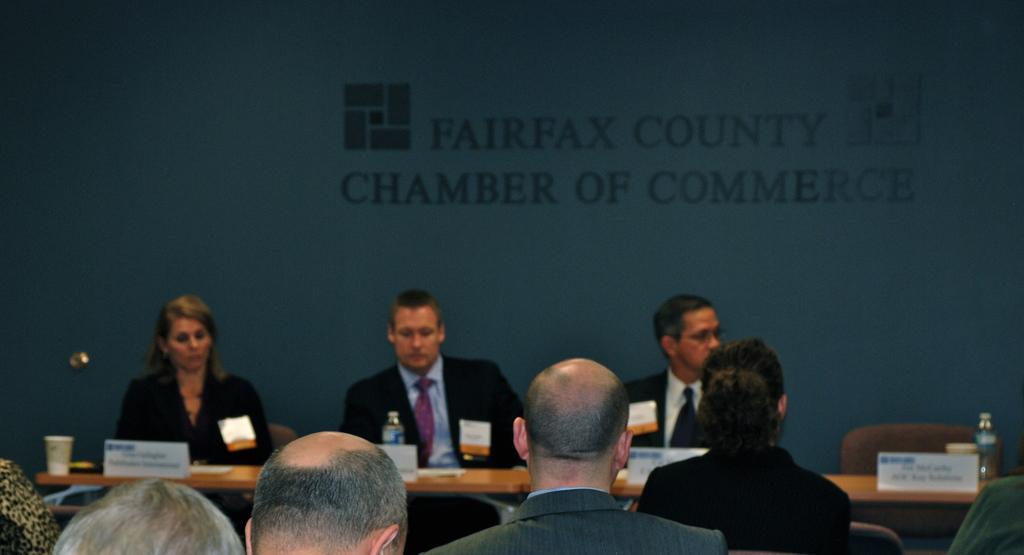Please provide a concise description of this image. In this image I can see few people are sitting on chairs. I can see all of them are wearing formal dress. I can also see a table and on it I can see few boards, a glass, a bottle and on these boards I can see something is written. In the background I can see something is written over here. 